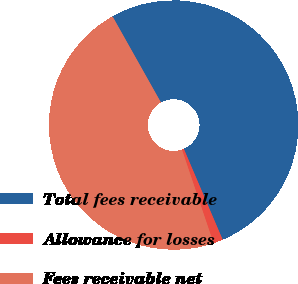Convert chart to OTSL. <chart><loc_0><loc_0><loc_500><loc_500><pie_chart><fcel>Total fees receivable<fcel>Allowance for losses<fcel>Fees receivable net<nl><fcel>51.73%<fcel>1.25%<fcel>47.03%<nl></chart> 